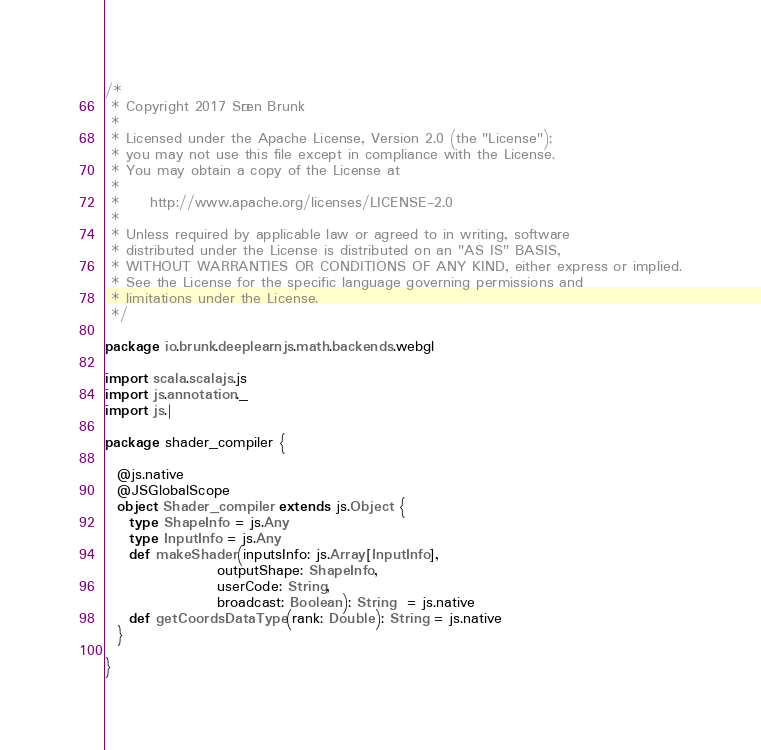<code> <loc_0><loc_0><loc_500><loc_500><_Scala_>/*
 * Copyright 2017 Sören Brunk
 *
 * Licensed under the Apache License, Version 2.0 (the "License");
 * you may not use this file except in compliance with the License.
 * You may obtain a copy of the License at
 *
 *     http://www.apache.org/licenses/LICENSE-2.0
 *
 * Unless required by applicable law or agreed to in writing, software
 * distributed under the License is distributed on an "AS IS" BASIS,
 * WITHOUT WARRANTIES OR CONDITIONS OF ANY KIND, either express or implied.
 * See the License for the specific language governing permissions and
 * limitations under the License.
 */

package io.brunk.deeplearnjs.math.backends.webgl

import scala.scalajs.js
import js.annotation._
import js.|

package shader_compiler {

  @js.native
  @JSGlobalScope
  object Shader_compiler extends js.Object {
    type ShapeInfo = js.Any
    type InputInfo = js.Any
    def makeShader(inputsInfo: js.Array[InputInfo],
                   outputShape: ShapeInfo,
                   userCode: String,
                   broadcast: Boolean): String  = js.native
    def getCoordsDataType(rank: Double): String = js.native
  }

}
</code> 